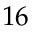Convert formula to latex. <formula><loc_0><loc_0><loc_500><loc_500>1 6</formula> 